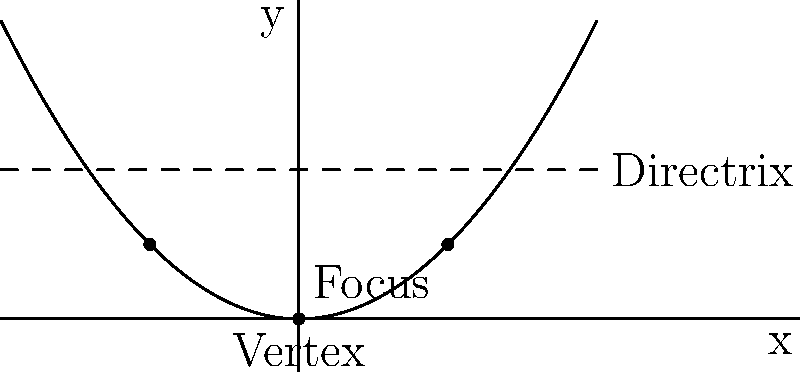In the context of analyzing political trends, consider the parabola shown above as a representation of public opinion over time on a specific policy issue. The vertex represents a turning point in public sentiment. Given that the equation of this parabola is $y = 0.25x^2$, what is the distance between the focus and the directrix of this parabola? To find the distance between the focus and the directrix, we'll follow these steps:

1) For a parabola with equation $y = ax^2$, the distance from the vertex to the focus is $\frac{1}{4a}$, and the distance from the vertex to the directrix is also $\frac{1}{4a}$.

2) In our case, $a = 0.25$, so the distance from the vertex to the focus (or directrix) is:

   $\frac{1}{4(0.25)} = \frac{1}{1} = 1$

3) Since the focus is 1 unit above the vertex and the directrix is 1 unit above the focus, the total distance between the focus and the directrix is:

   $1 + 1 = 2$

This distance represents the rate of change in public opinion, with a larger distance indicating more rapid shifts in sentiment.
Answer: 2 units 